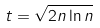Convert formula to latex. <formula><loc_0><loc_0><loc_500><loc_500>t = \sqrt { 2 n \ln n }</formula> 